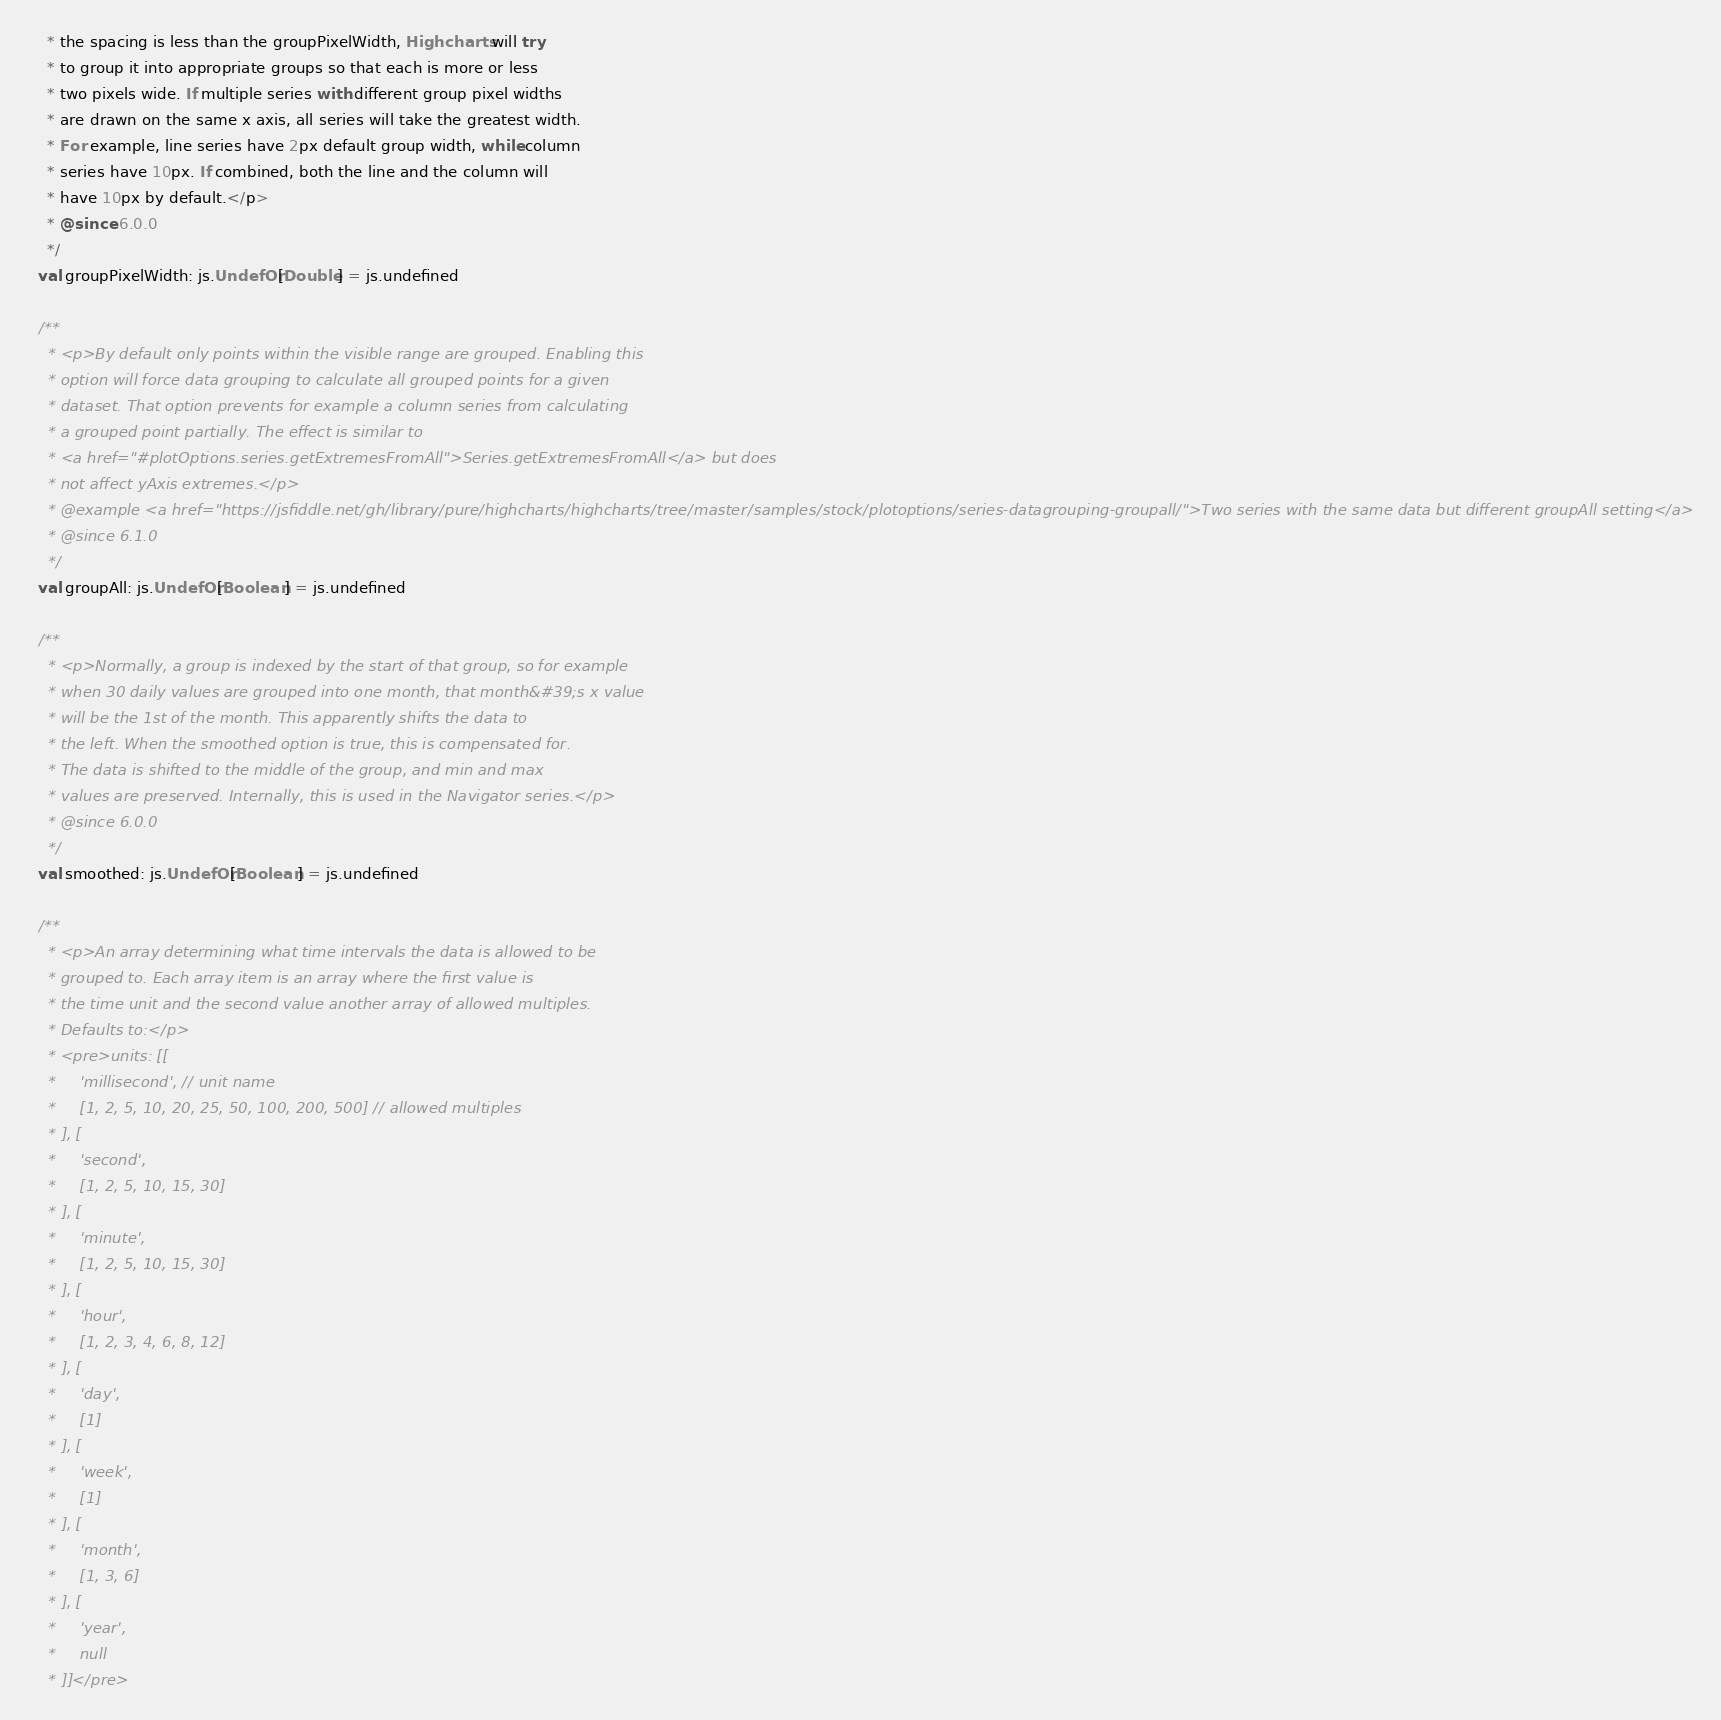Convert code to text. <code><loc_0><loc_0><loc_500><loc_500><_Scala_>    * the spacing is less than the groupPixelWidth, Highcharts will try
    * to group it into appropriate groups so that each is more or less
    * two pixels wide. If multiple series with different group pixel widths
    * are drawn on the same x axis, all series will take the greatest width.
    * For example, line series have 2px default group width, while column
    * series have 10px. If combined, both the line and the column will
    * have 10px by default.</p>
    * @since 6.0.0
    */
  val groupPixelWidth: js.UndefOr[Double] = js.undefined

  /**
    * <p>By default only points within the visible range are grouped. Enabling this
    * option will force data grouping to calculate all grouped points for a given
    * dataset. That option prevents for example a column series from calculating
    * a grouped point partially. The effect is similar to
    * <a href="#plotOptions.series.getExtremesFromAll">Series.getExtremesFromAll</a> but does
    * not affect yAxis extremes.</p>
    * @example <a href="https://jsfiddle.net/gh/library/pure/highcharts/highcharts/tree/master/samples/stock/plotoptions/series-datagrouping-groupall/">Two series with the same data but different groupAll setting</a>
    * @since 6.1.0
    */
  val groupAll: js.UndefOr[Boolean] = js.undefined

  /**
    * <p>Normally, a group is indexed by the start of that group, so for example
    * when 30 daily values are grouped into one month, that month&#39;s x value
    * will be the 1st of the month. This apparently shifts the data to
    * the left. When the smoothed option is true, this is compensated for.
    * The data is shifted to the middle of the group, and min and max
    * values are preserved. Internally, this is used in the Navigator series.</p>
    * @since 6.0.0
    */
  val smoothed: js.UndefOr[Boolean] = js.undefined

  /**
    * <p>An array determining what time intervals the data is allowed to be
    * grouped to. Each array item is an array where the first value is
    * the time unit and the second value another array of allowed multiples.
    * Defaults to:</p>
    * <pre>units: [[
    *     'millisecond', // unit name
    *     [1, 2, 5, 10, 20, 25, 50, 100, 200, 500] // allowed multiples
    * ], [
    *     'second',
    *     [1, 2, 5, 10, 15, 30]
    * ], [
    *     'minute',
    *     [1, 2, 5, 10, 15, 30]
    * ], [
    *     'hour',
    *     [1, 2, 3, 4, 6, 8, 12]
    * ], [
    *     'day',
    *     [1]
    * ], [
    *     'week',
    *     [1]
    * ], [
    *     'month',
    *     [1, 3, 6]
    * ], [
    *     'year',
    *     null
    * ]]</pre></code> 